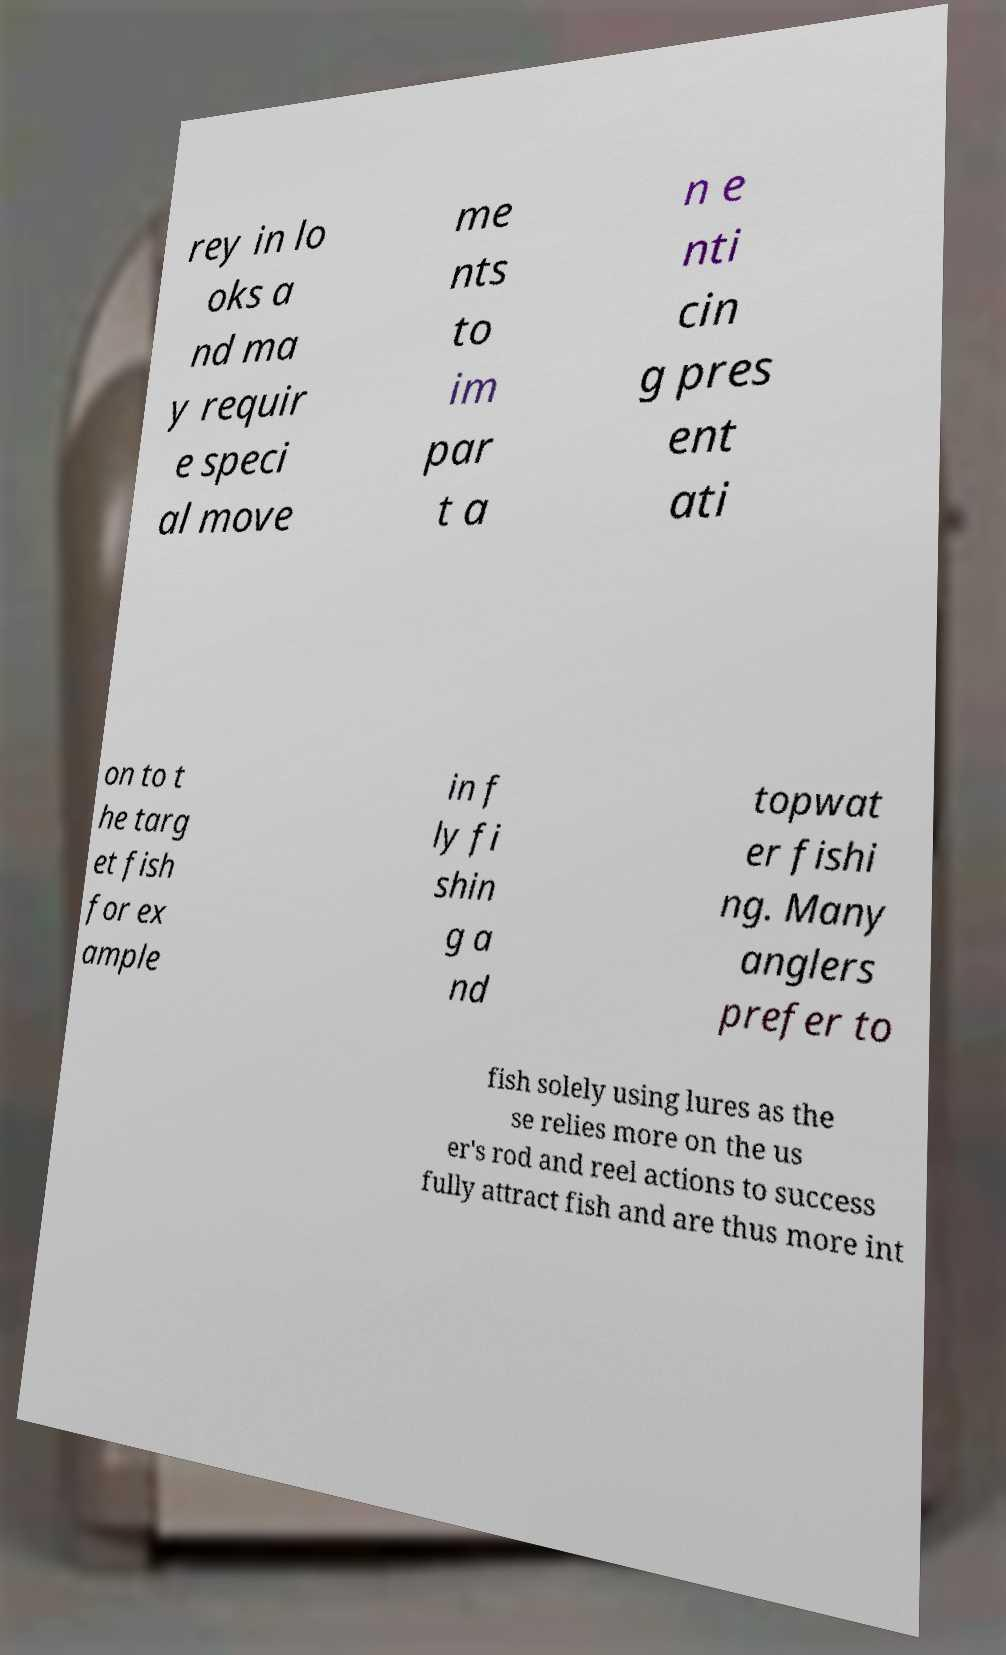Could you assist in decoding the text presented in this image and type it out clearly? rey in lo oks a nd ma y requir e speci al move me nts to im par t a n e nti cin g pres ent ati on to t he targ et fish for ex ample in f ly fi shin g a nd topwat er fishi ng. Many anglers prefer to fish solely using lures as the se relies more on the us er's rod and reel actions to success fully attract fish and are thus more int 